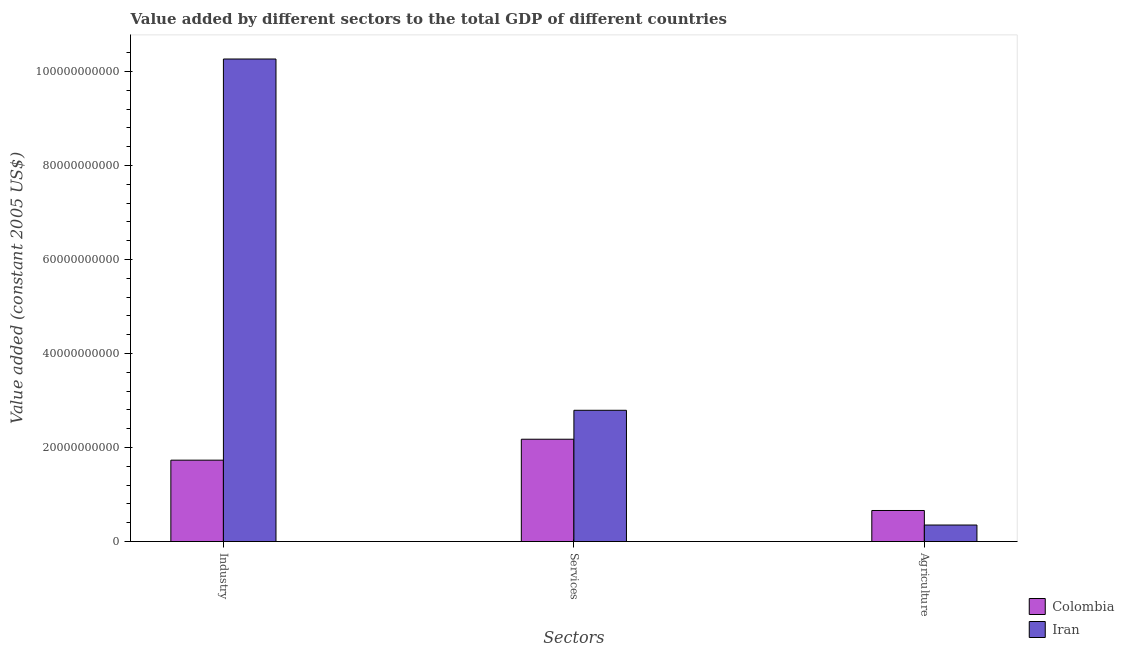How many different coloured bars are there?
Your answer should be compact. 2. How many groups of bars are there?
Provide a succinct answer. 3. Are the number of bars per tick equal to the number of legend labels?
Make the answer very short. Yes. Are the number of bars on each tick of the X-axis equal?
Provide a succinct answer. Yes. How many bars are there on the 1st tick from the left?
Make the answer very short. 2. How many bars are there on the 3rd tick from the right?
Provide a succinct answer. 2. What is the label of the 3rd group of bars from the left?
Ensure brevity in your answer.  Agriculture. What is the value added by services in Colombia?
Provide a succinct answer. 2.18e+1. Across all countries, what is the maximum value added by services?
Ensure brevity in your answer.  2.79e+1. Across all countries, what is the minimum value added by services?
Your answer should be compact. 2.18e+1. In which country was the value added by services maximum?
Offer a terse response. Iran. In which country was the value added by agricultural sector minimum?
Ensure brevity in your answer.  Iran. What is the total value added by industrial sector in the graph?
Your answer should be compact. 1.20e+11. What is the difference between the value added by industrial sector in Colombia and that in Iran?
Keep it short and to the point. -8.53e+1. What is the difference between the value added by services in Colombia and the value added by industrial sector in Iran?
Provide a succinct answer. -8.09e+1. What is the average value added by agricultural sector per country?
Provide a succinct answer. 5.06e+09. What is the difference between the value added by services and value added by agricultural sector in Iran?
Your answer should be very brief. 2.44e+1. What is the ratio of the value added by services in Colombia to that in Iran?
Your answer should be compact. 0.78. Is the difference between the value added by agricultural sector in Colombia and Iran greater than the difference between the value added by services in Colombia and Iran?
Provide a short and direct response. Yes. What is the difference between the highest and the second highest value added by industrial sector?
Make the answer very short. 8.53e+1. What is the difference between the highest and the lowest value added by services?
Offer a very short reply. 6.16e+09. What does the 1st bar from the left in Industry represents?
Offer a very short reply. Colombia. What does the 1st bar from the right in Agriculture represents?
Give a very brief answer. Iran. How many bars are there?
Keep it short and to the point. 6. What is the difference between two consecutive major ticks on the Y-axis?
Your answer should be very brief. 2.00e+1. Does the graph contain any zero values?
Offer a terse response. No. Does the graph contain grids?
Provide a succinct answer. No. Where does the legend appear in the graph?
Provide a succinct answer. Bottom right. How many legend labels are there?
Your response must be concise. 2. What is the title of the graph?
Ensure brevity in your answer.  Value added by different sectors to the total GDP of different countries. What is the label or title of the X-axis?
Keep it short and to the point. Sectors. What is the label or title of the Y-axis?
Your answer should be very brief. Value added (constant 2005 US$). What is the Value added (constant 2005 US$) of Colombia in Industry?
Give a very brief answer. 1.73e+1. What is the Value added (constant 2005 US$) of Iran in Industry?
Provide a short and direct response. 1.03e+11. What is the Value added (constant 2005 US$) of Colombia in Services?
Make the answer very short. 2.18e+1. What is the Value added (constant 2005 US$) of Iran in Services?
Give a very brief answer. 2.79e+1. What is the Value added (constant 2005 US$) in Colombia in Agriculture?
Make the answer very short. 6.61e+09. What is the Value added (constant 2005 US$) of Iran in Agriculture?
Keep it short and to the point. 3.52e+09. Across all Sectors, what is the maximum Value added (constant 2005 US$) of Colombia?
Provide a short and direct response. 2.18e+1. Across all Sectors, what is the maximum Value added (constant 2005 US$) in Iran?
Your response must be concise. 1.03e+11. Across all Sectors, what is the minimum Value added (constant 2005 US$) in Colombia?
Make the answer very short. 6.61e+09. Across all Sectors, what is the minimum Value added (constant 2005 US$) of Iran?
Keep it short and to the point. 3.52e+09. What is the total Value added (constant 2005 US$) of Colombia in the graph?
Give a very brief answer. 4.57e+1. What is the total Value added (constant 2005 US$) in Iran in the graph?
Ensure brevity in your answer.  1.34e+11. What is the difference between the Value added (constant 2005 US$) in Colombia in Industry and that in Services?
Provide a succinct answer. -4.46e+09. What is the difference between the Value added (constant 2005 US$) of Iran in Industry and that in Services?
Your answer should be very brief. 7.47e+1. What is the difference between the Value added (constant 2005 US$) of Colombia in Industry and that in Agriculture?
Provide a succinct answer. 1.07e+1. What is the difference between the Value added (constant 2005 US$) of Iran in Industry and that in Agriculture?
Offer a very short reply. 9.91e+1. What is the difference between the Value added (constant 2005 US$) of Colombia in Services and that in Agriculture?
Make the answer very short. 1.52e+1. What is the difference between the Value added (constant 2005 US$) of Iran in Services and that in Agriculture?
Offer a very short reply. 2.44e+1. What is the difference between the Value added (constant 2005 US$) of Colombia in Industry and the Value added (constant 2005 US$) of Iran in Services?
Offer a terse response. -1.06e+1. What is the difference between the Value added (constant 2005 US$) of Colombia in Industry and the Value added (constant 2005 US$) of Iran in Agriculture?
Offer a terse response. 1.38e+1. What is the difference between the Value added (constant 2005 US$) in Colombia in Services and the Value added (constant 2005 US$) in Iran in Agriculture?
Make the answer very short. 1.83e+1. What is the average Value added (constant 2005 US$) in Colombia per Sectors?
Keep it short and to the point. 1.52e+1. What is the average Value added (constant 2005 US$) of Iran per Sectors?
Make the answer very short. 4.47e+1. What is the difference between the Value added (constant 2005 US$) of Colombia and Value added (constant 2005 US$) of Iran in Industry?
Offer a very short reply. -8.53e+1. What is the difference between the Value added (constant 2005 US$) in Colombia and Value added (constant 2005 US$) in Iran in Services?
Keep it short and to the point. -6.16e+09. What is the difference between the Value added (constant 2005 US$) in Colombia and Value added (constant 2005 US$) in Iran in Agriculture?
Offer a very short reply. 3.09e+09. What is the ratio of the Value added (constant 2005 US$) in Colombia in Industry to that in Services?
Offer a very short reply. 0.8. What is the ratio of the Value added (constant 2005 US$) in Iran in Industry to that in Services?
Give a very brief answer. 3.68. What is the ratio of the Value added (constant 2005 US$) of Colombia in Industry to that in Agriculture?
Make the answer very short. 2.62. What is the ratio of the Value added (constant 2005 US$) in Iran in Industry to that in Agriculture?
Ensure brevity in your answer.  29.18. What is the ratio of the Value added (constant 2005 US$) of Colombia in Services to that in Agriculture?
Your answer should be very brief. 3.29. What is the ratio of the Value added (constant 2005 US$) in Iran in Services to that in Agriculture?
Your answer should be very brief. 7.94. What is the difference between the highest and the second highest Value added (constant 2005 US$) in Colombia?
Keep it short and to the point. 4.46e+09. What is the difference between the highest and the second highest Value added (constant 2005 US$) in Iran?
Offer a terse response. 7.47e+1. What is the difference between the highest and the lowest Value added (constant 2005 US$) in Colombia?
Your answer should be very brief. 1.52e+1. What is the difference between the highest and the lowest Value added (constant 2005 US$) of Iran?
Offer a terse response. 9.91e+1. 